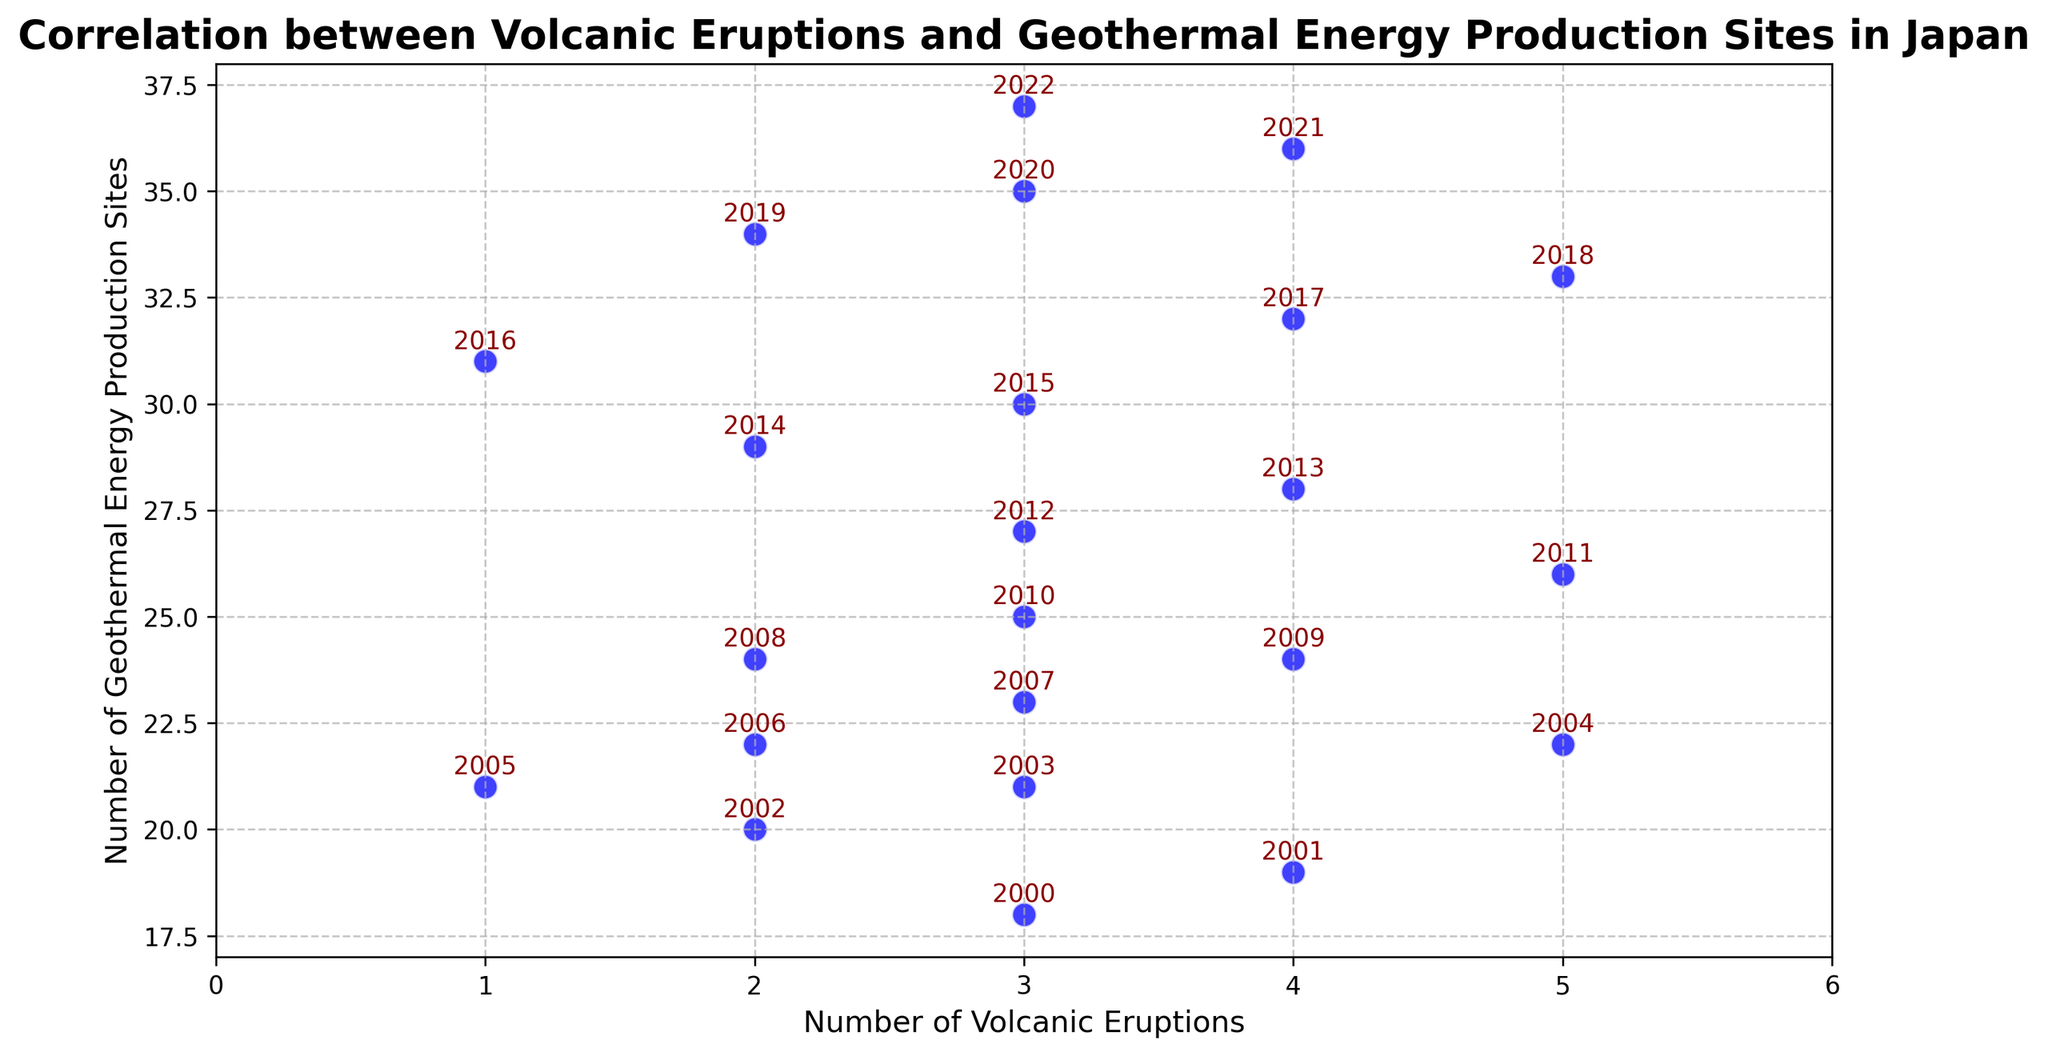What is the range of the number of geothermal energy production sites shown in the figure? The range is calculated by subtracting the smallest value from the largest value. The smallest number of sites is 18 and the largest is 37, so the range is 37 - 18.
Answer: 19 Which year had the highest number of volcanic eruptions? Looking at the scatter plot points labeled with the years, identify the year with the highest value on the x-axis. The year with the highest number of volcanic eruptions (5) appears to be 2004, 2011, and 2018.
Answer: 2004, 2011, 2018 What is the average number of geothermal energy production sites over the whole period? First, sum all the geothermal energy production site values, then divide by the total number of years to find the average. (18 + 19 + 20 + 21 + 22 + 21 + 22 + 23 + 24 + 24 + 25 + 26 + 27 + 28 + 29 + 30 + 31 + 32 + 33 + 34 + 35 + 36 + 37) / 23 = 604 / 23.
Answer: 26.26 Which year had 4 volcanic eruptions and how many geothermal energy production sites were there in that year? Locate the scatter plot points corresponding to 4 on the x-axis and check the years labeled. Those years are 2001, 2009, 2013, 2017, and 2021. The respective number of geothermal energy production sites are 19, 24, 28, 32, and 36.
Answer: 19 (2001), 24 (2009), 28 (2013), 32 (2017), 36 (2021) What was the overall trend in the number of geothermal energy production sites from 2000 to 2022? Analyze the tendency of the y-values corresponding to the geothermal energy production sites' values over the years from left to right on the scatter plot. The number of geothermal energy production sites shows an increasing trend from 18 in 2000 to 37 in 2022.
Answer: Increasing How many years had the same number of volcanic eruptions but a different number of geothermal energy production sites? Identify points with the same x-value (volcanic eruptions) but different y-values (geothermal sites). These are: 2 eruptions (2002, 2006, 2008, 2014, 2019), 3 eruptions (2000, 2003, 2007, 2010, 2012, 2015, 2020, 2022), and 4 eruptions (2001, 2009, 2013, 2017, 2021). Count each set of differing y-values for the same x-values. There are 5 + 8 + 5 = 18 years.
Answer: 18 What is the average number of eruptions per year over the period? Sum the volcanic eruption values and divide by the total number of years. (3 + 4 + 2 + 3 + 5 + 1 + 2 + 3 + 2 + 4 + 3 + 5 + 3 + 4 + 2 + 3 + 1 + 4 + 5 + 2 + 3 + 4 + 3) / 23.
Answer: 3 In which year did both the number of volcanic eruptions and geothermal energy production sites hit their maximum? Identify the highest values on both axes and look for corresponding years. The maximum number of geothermal energy production sites (37) is in 2022, and the maximum number of volcanic eruptions (5) occurred in 2004, 2011, and 2018. The year 2022 appears only for the maximum geothermal sites.
Answer: 2022 Is there any year with a unique minimum or maximum value for volcanic eruptions or geothermal energy production sites? Check the scatter plot for unique minimum and maximum values. The unique minimum volcanic eruptions year is 2005 and 2016 (1 eruption), and the unique maximum geothermal sites value is 2022 (37 sites) without a shared year for eruptions’ maximum.
Answer: 2005, 2016 (min eruptions); 2022 (max sites) Which period saw the most stable number of geothermal energy production sites, and what is the average number of eruptions during this period? Gauge the sections of the scatter plot with minimum variance in y-values (geothermal sites). For instance, 2000-2005 ranges from 18 to 22 sites with relatively minimum fluctuation. Then check the average x-values (volcanic eruptions) in this period. Average number of eruptions: (3 + 4 + 2 + 3 + 5 + 1) / 6 = 3.
Answer: 2000-2005, 3 